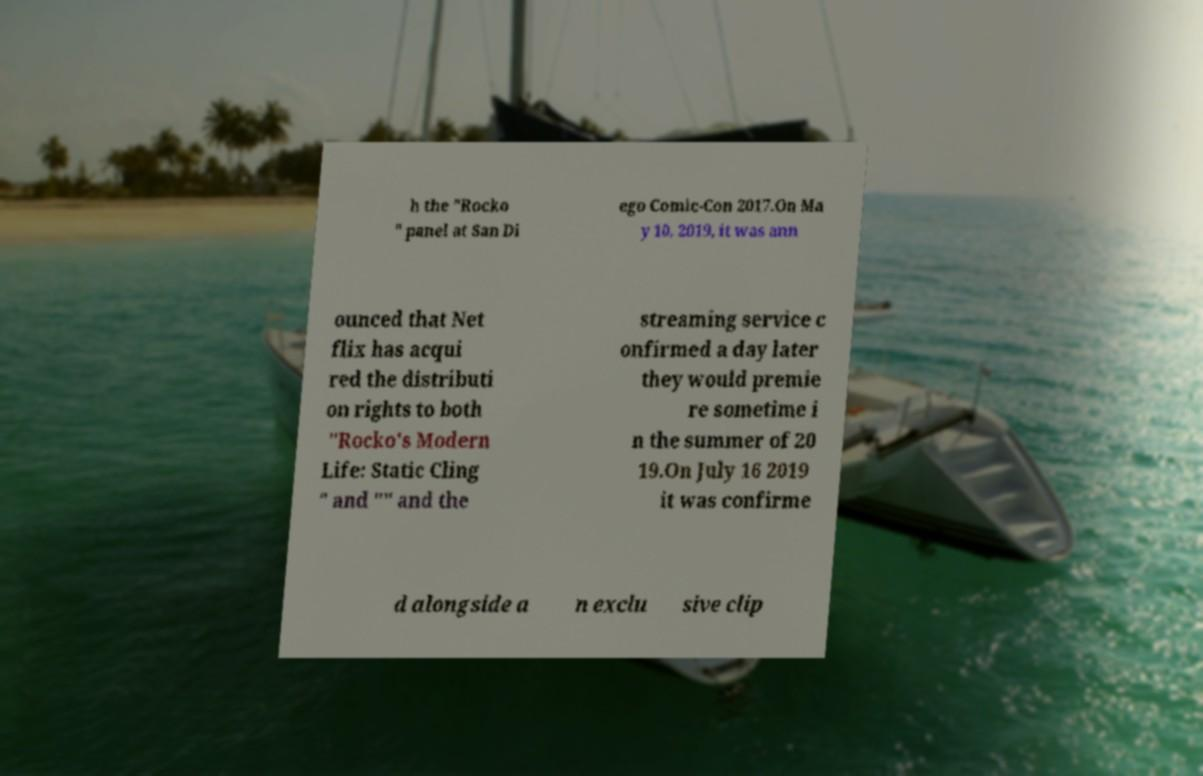Can you accurately transcribe the text from the provided image for me? h the "Rocko " panel at San Di ego Comic-Con 2017.On Ma y 10, 2019, it was ann ounced that Net flix has acqui red the distributi on rights to both "Rocko's Modern Life: Static Cling " and "" and the streaming service c onfirmed a day later they would premie re sometime i n the summer of 20 19.On July 16 2019 it was confirme d alongside a n exclu sive clip 